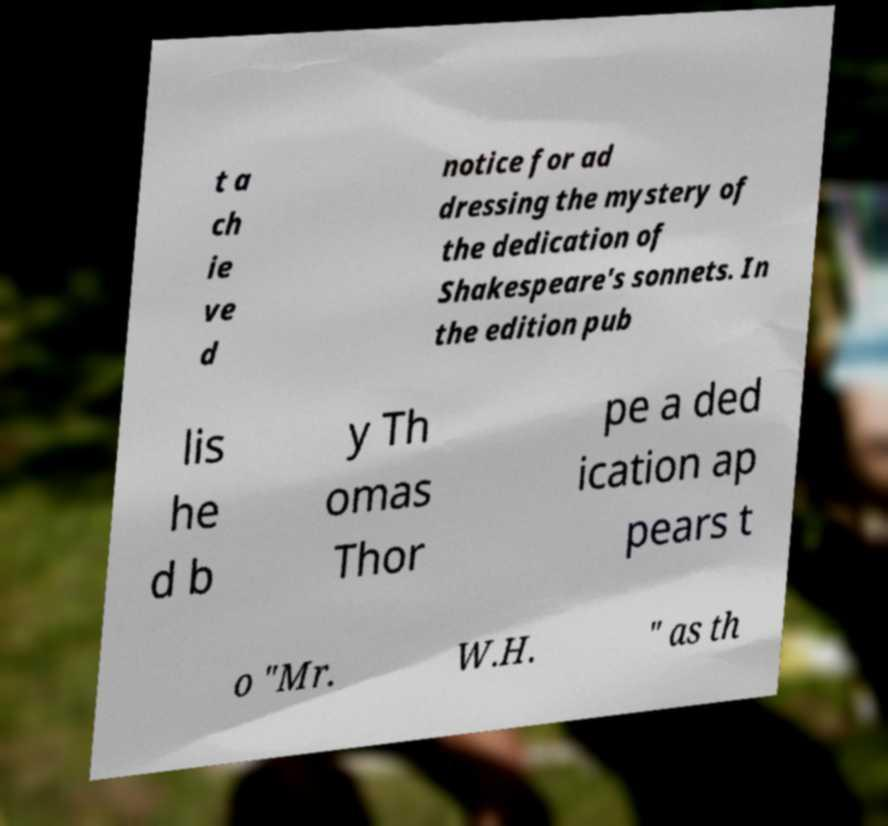Could you extract and type out the text from this image? t a ch ie ve d notice for ad dressing the mystery of the dedication of Shakespeare's sonnets. In the edition pub lis he d b y Th omas Thor pe a ded ication ap pears t o "Mr. W.H. " as th 